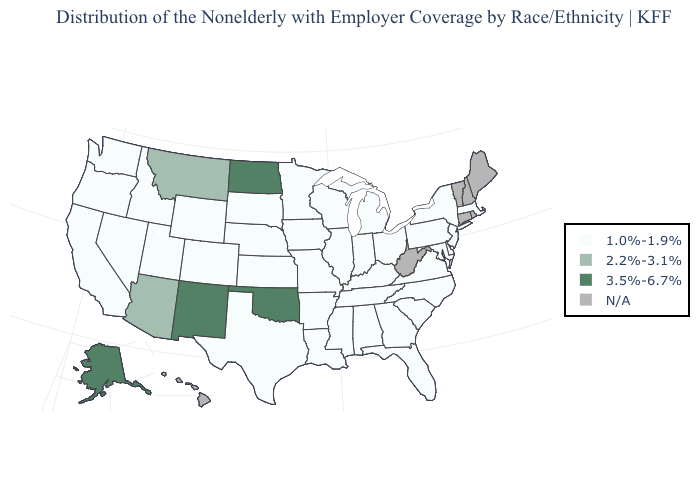How many symbols are there in the legend?
Short answer required. 4. Which states have the lowest value in the USA?
Short answer required. Alabama, Arkansas, California, Colorado, Delaware, Florida, Georgia, Idaho, Illinois, Indiana, Iowa, Kansas, Kentucky, Louisiana, Maryland, Massachusetts, Michigan, Minnesota, Mississippi, Missouri, Nebraska, Nevada, New Jersey, New York, North Carolina, Ohio, Oregon, Pennsylvania, South Carolina, South Dakota, Tennessee, Texas, Utah, Virginia, Washington, Wisconsin, Wyoming. Name the states that have a value in the range 3.5%-6.7%?
Keep it brief. Alaska, New Mexico, North Dakota, Oklahoma. Among the states that border Oklahoma , does Missouri have the lowest value?
Concise answer only. Yes. Does North Dakota have the lowest value in the USA?
Be succinct. No. Which states have the highest value in the USA?
Be succinct. Alaska, New Mexico, North Dakota, Oklahoma. What is the value of New Hampshire?
Quick response, please. N/A. Name the states that have a value in the range 1.0%-1.9%?
Answer briefly. Alabama, Arkansas, California, Colorado, Delaware, Florida, Georgia, Idaho, Illinois, Indiana, Iowa, Kansas, Kentucky, Louisiana, Maryland, Massachusetts, Michigan, Minnesota, Mississippi, Missouri, Nebraska, Nevada, New Jersey, New York, North Carolina, Ohio, Oregon, Pennsylvania, South Carolina, South Dakota, Tennessee, Texas, Utah, Virginia, Washington, Wisconsin, Wyoming. Name the states that have a value in the range 1.0%-1.9%?
Quick response, please. Alabama, Arkansas, California, Colorado, Delaware, Florida, Georgia, Idaho, Illinois, Indiana, Iowa, Kansas, Kentucky, Louisiana, Maryland, Massachusetts, Michigan, Minnesota, Mississippi, Missouri, Nebraska, Nevada, New Jersey, New York, North Carolina, Ohio, Oregon, Pennsylvania, South Carolina, South Dakota, Tennessee, Texas, Utah, Virginia, Washington, Wisconsin, Wyoming. Name the states that have a value in the range 1.0%-1.9%?
Quick response, please. Alabama, Arkansas, California, Colorado, Delaware, Florida, Georgia, Idaho, Illinois, Indiana, Iowa, Kansas, Kentucky, Louisiana, Maryland, Massachusetts, Michigan, Minnesota, Mississippi, Missouri, Nebraska, Nevada, New Jersey, New York, North Carolina, Ohio, Oregon, Pennsylvania, South Carolina, South Dakota, Tennessee, Texas, Utah, Virginia, Washington, Wisconsin, Wyoming. What is the value of New York?
Concise answer only. 1.0%-1.9%. What is the lowest value in the USA?
Answer briefly. 1.0%-1.9%. Name the states that have a value in the range 1.0%-1.9%?
Short answer required. Alabama, Arkansas, California, Colorado, Delaware, Florida, Georgia, Idaho, Illinois, Indiana, Iowa, Kansas, Kentucky, Louisiana, Maryland, Massachusetts, Michigan, Minnesota, Mississippi, Missouri, Nebraska, Nevada, New Jersey, New York, North Carolina, Ohio, Oregon, Pennsylvania, South Carolina, South Dakota, Tennessee, Texas, Utah, Virginia, Washington, Wisconsin, Wyoming. What is the highest value in the South ?
Give a very brief answer. 3.5%-6.7%. What is the value of New York?
Keep it brief. 1.0%-1.9%. 